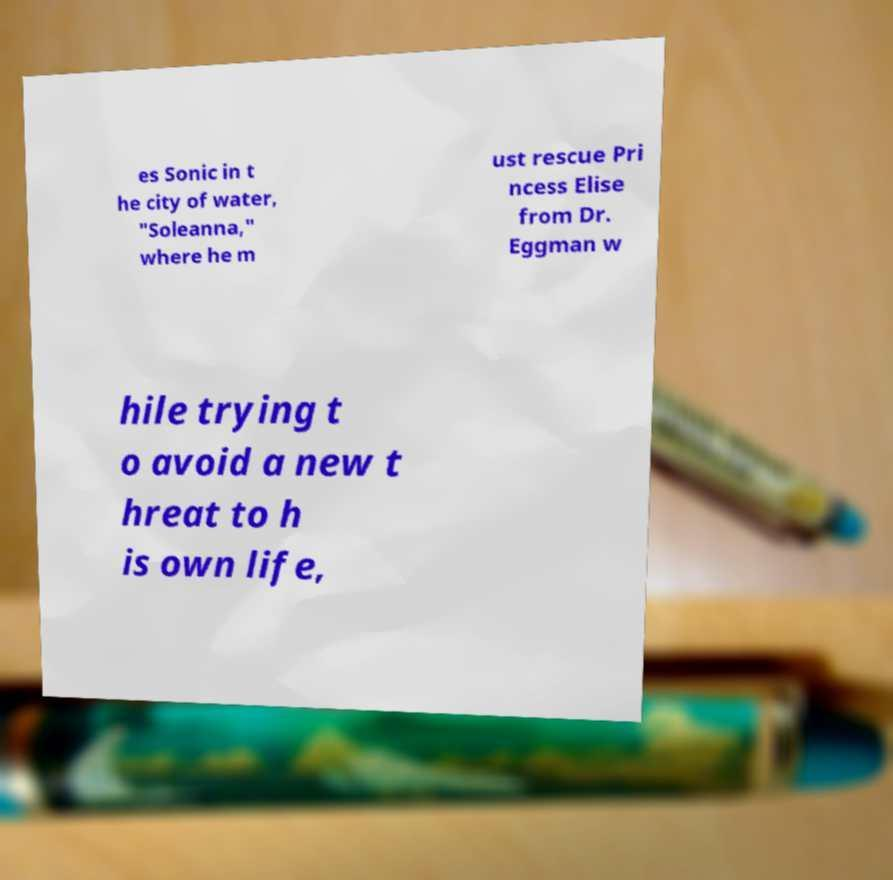For documentation purposes, I need the text within this image transcribed. Could you provide that? es Sonic in t he city of water, "Soleanna," where he m ust rescue Pri ncess Elise from Dr. Eggman w hile trying t o avoid a new t hreat to h is own life, 